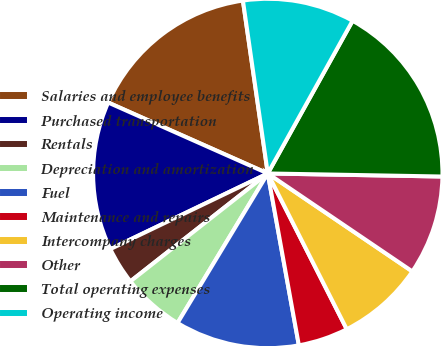Convert chart. <chart><loc_0><loc_0><loc_500><loc_500><pie_chart><fcel>Salaries and employee benefits<fcel>Purchased transportation<fcel>Rentals<fcel>Depreciation and amortization<fcel>Fuel<fcel>Maintenance and repairs<fcel>Intercompany charges<fcel>Other<fcel>Total operating expenses<fcel>Operating income<nl><fcel>16.07%<fcel>13.78%<fcel>3.47%<fcel>5.76%<fcel>11.49%<fcel>4.62%<fcel>8.05%<fcel>9.2%<fcel>17.21%<fcel>10.34%<nl></chart> 